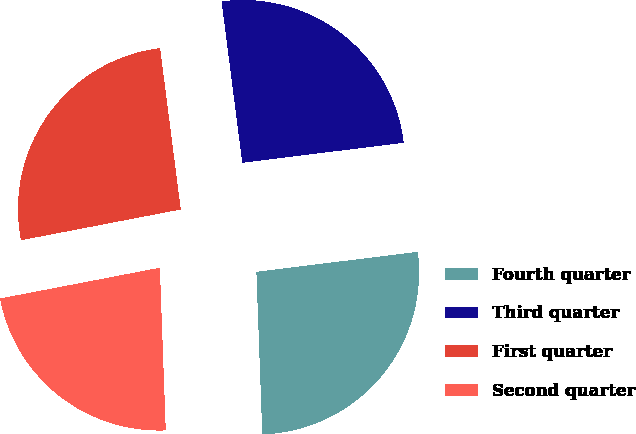Convert chart. <chart><loc_0><loc_0><loc_500><loc_500><pie_chart><fcel>Fourth quarter<fcel>Third quarter<fcel>First quarter<fcel>Second quarter<nl><fcel>26.38%<fcel>25.07%<fcel>26.0%<fcel>22.55%<nl></chart> 